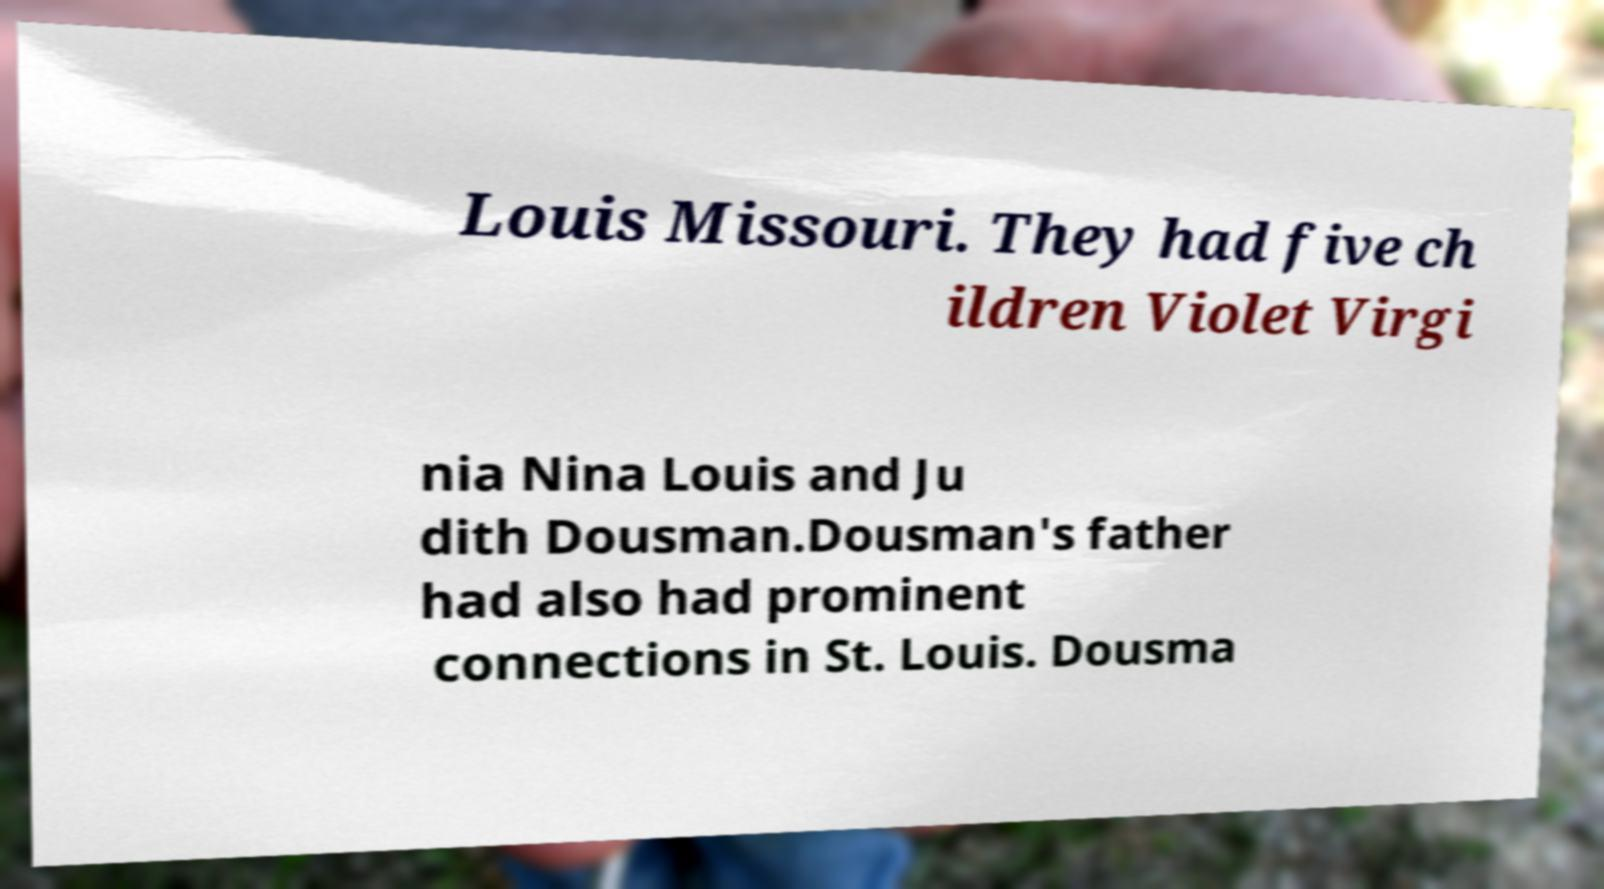Please identify and transcribe the text found in this image. Louis Missouri. They had five ch ildren Violet Virgi nia Nina Louis and Ju dith Dousman.Dousman's father had also had prominent connections in St. Louis. Dousma 